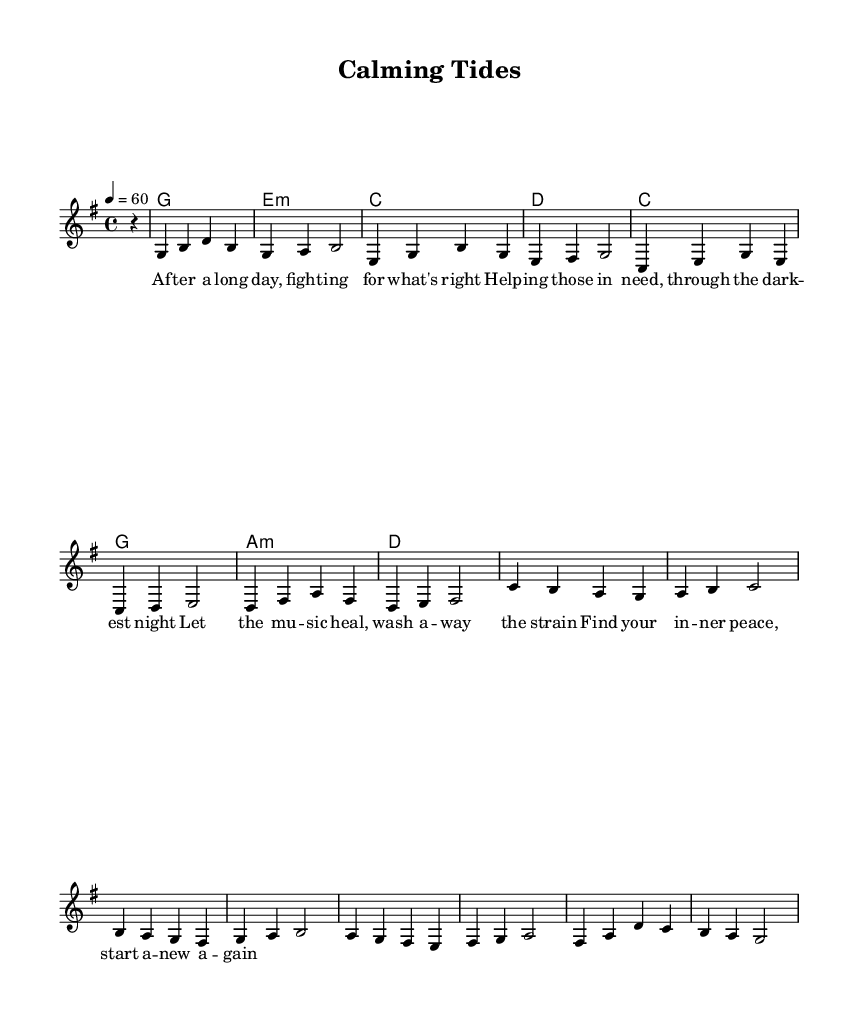What is the key signature of this music? The key signature indicates which notes are sharp or flat throughout the piece. In this case, there is one sharp, which means the key is G major.
Answer: G major What is the time signature of this music? The time signature is indicated at the beginning of the piece. Here, it shows 4/4, which means there are four beats in each measure, and the quarter note receives one beat.
Answer: 4/4 What is the tempo marking of this piece? The tempo marking appears at the start of the score and is expressed in beats per minute. It states "4 = 60," meaning the quarter note is to be played at 60 beats per minute.
Answer: 60 How many measures are in the melody? Counting the number of distinct phrases and separating them shows that there are 12 total measures in the melody section which contributes to the structure of the song.
Answer: 12 What is the first chord written in the piece? The first chord appears after the rest indicated in the chord section. The chord written here is G major, which is specified as the first chord in the score.
Answer: G What musical theme is conveyed through the lyrics? By closely examining the lyrics, it becomes clear that the theme centers on healing and finding calmness after a challenging experience or day, which resonates with the mellow acoustic rock style.
Answer: Healing and calmness Which chord appears three times in the chord progression? The chord section can be examined to find repetitions. The chord "C" is shown to repeat across the music, confirming its significance within this progression structure.
Answer: C 